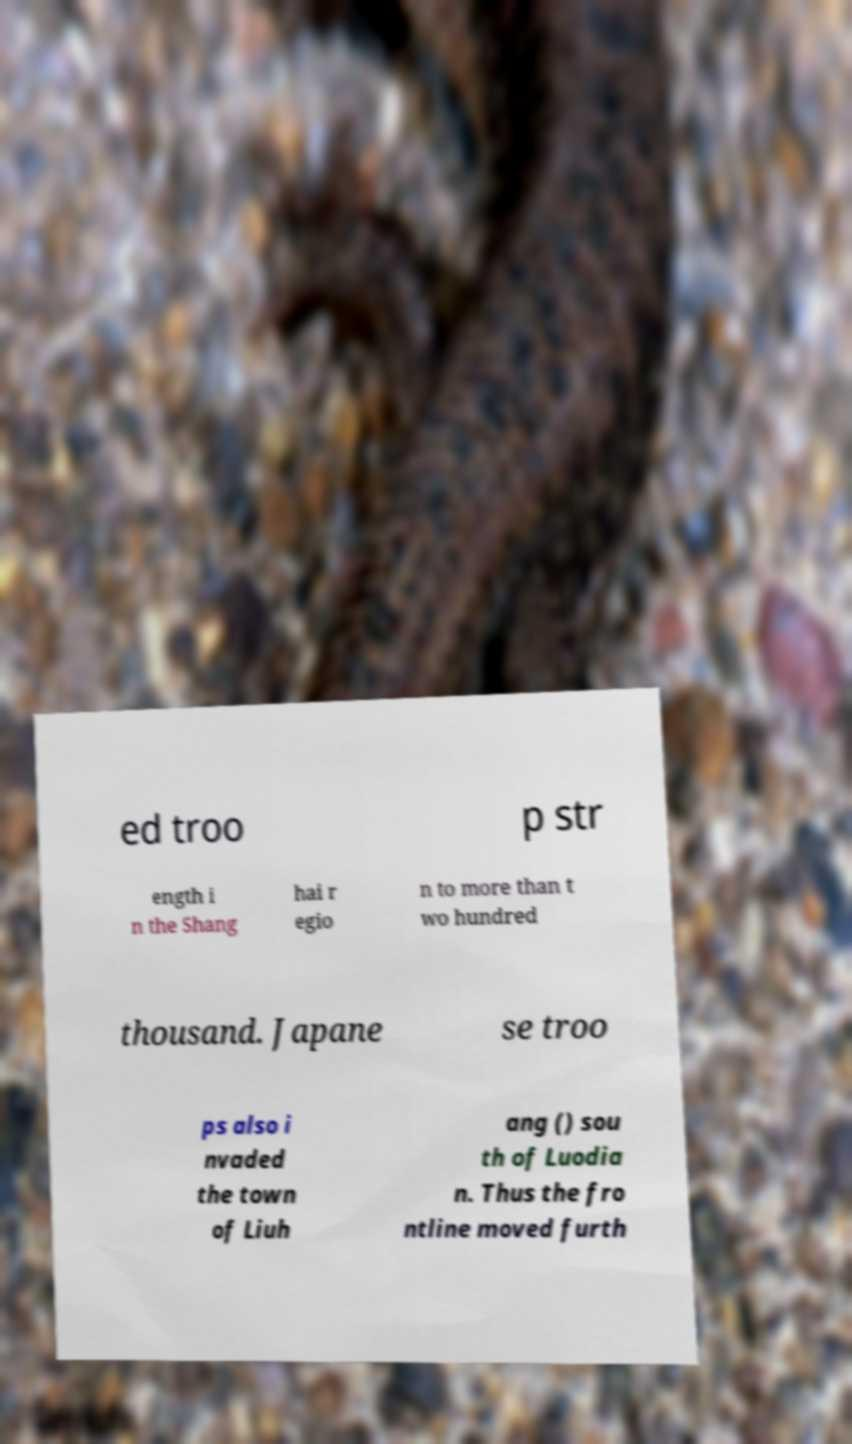What messages or text are displayed in this image? I need them in a readable, typed format. ed troo p str ength i n the Shang hai r egio n to more than t wo hundred thousand. Japane se troo ps also i nvaded the town of Liuh ang () sou th of Luodia n. Thus the fro ntline moved furth 